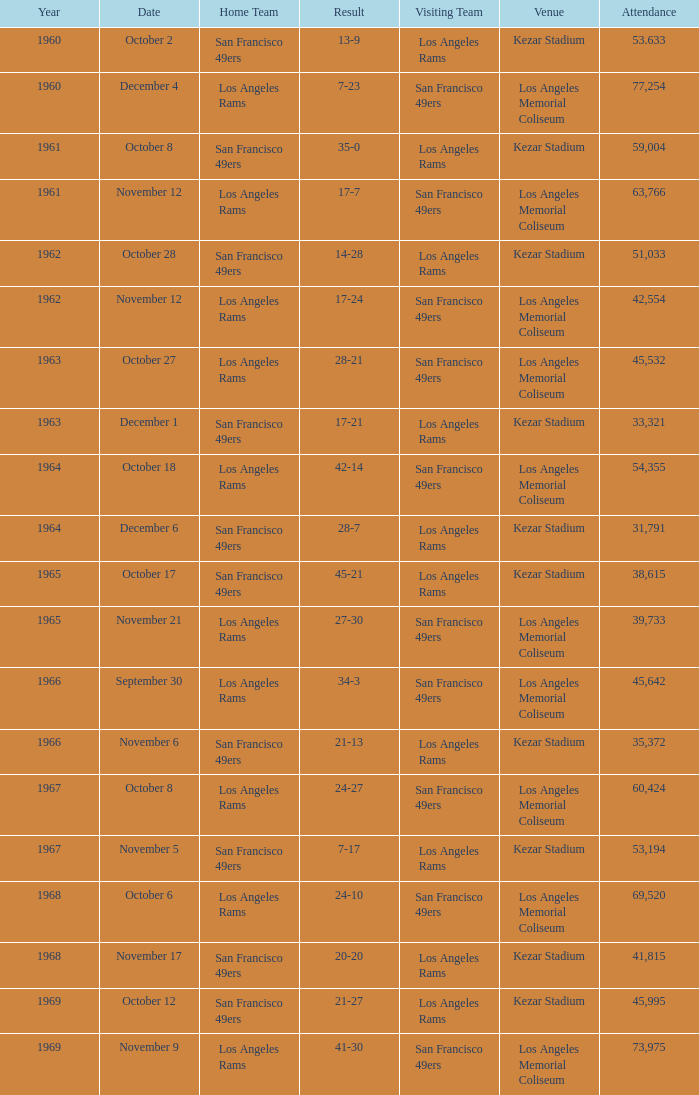When the san francisco 49ers are visiting with a turnout of over 45,532 on september 30, who was the host team? Los Angeles Rams. 